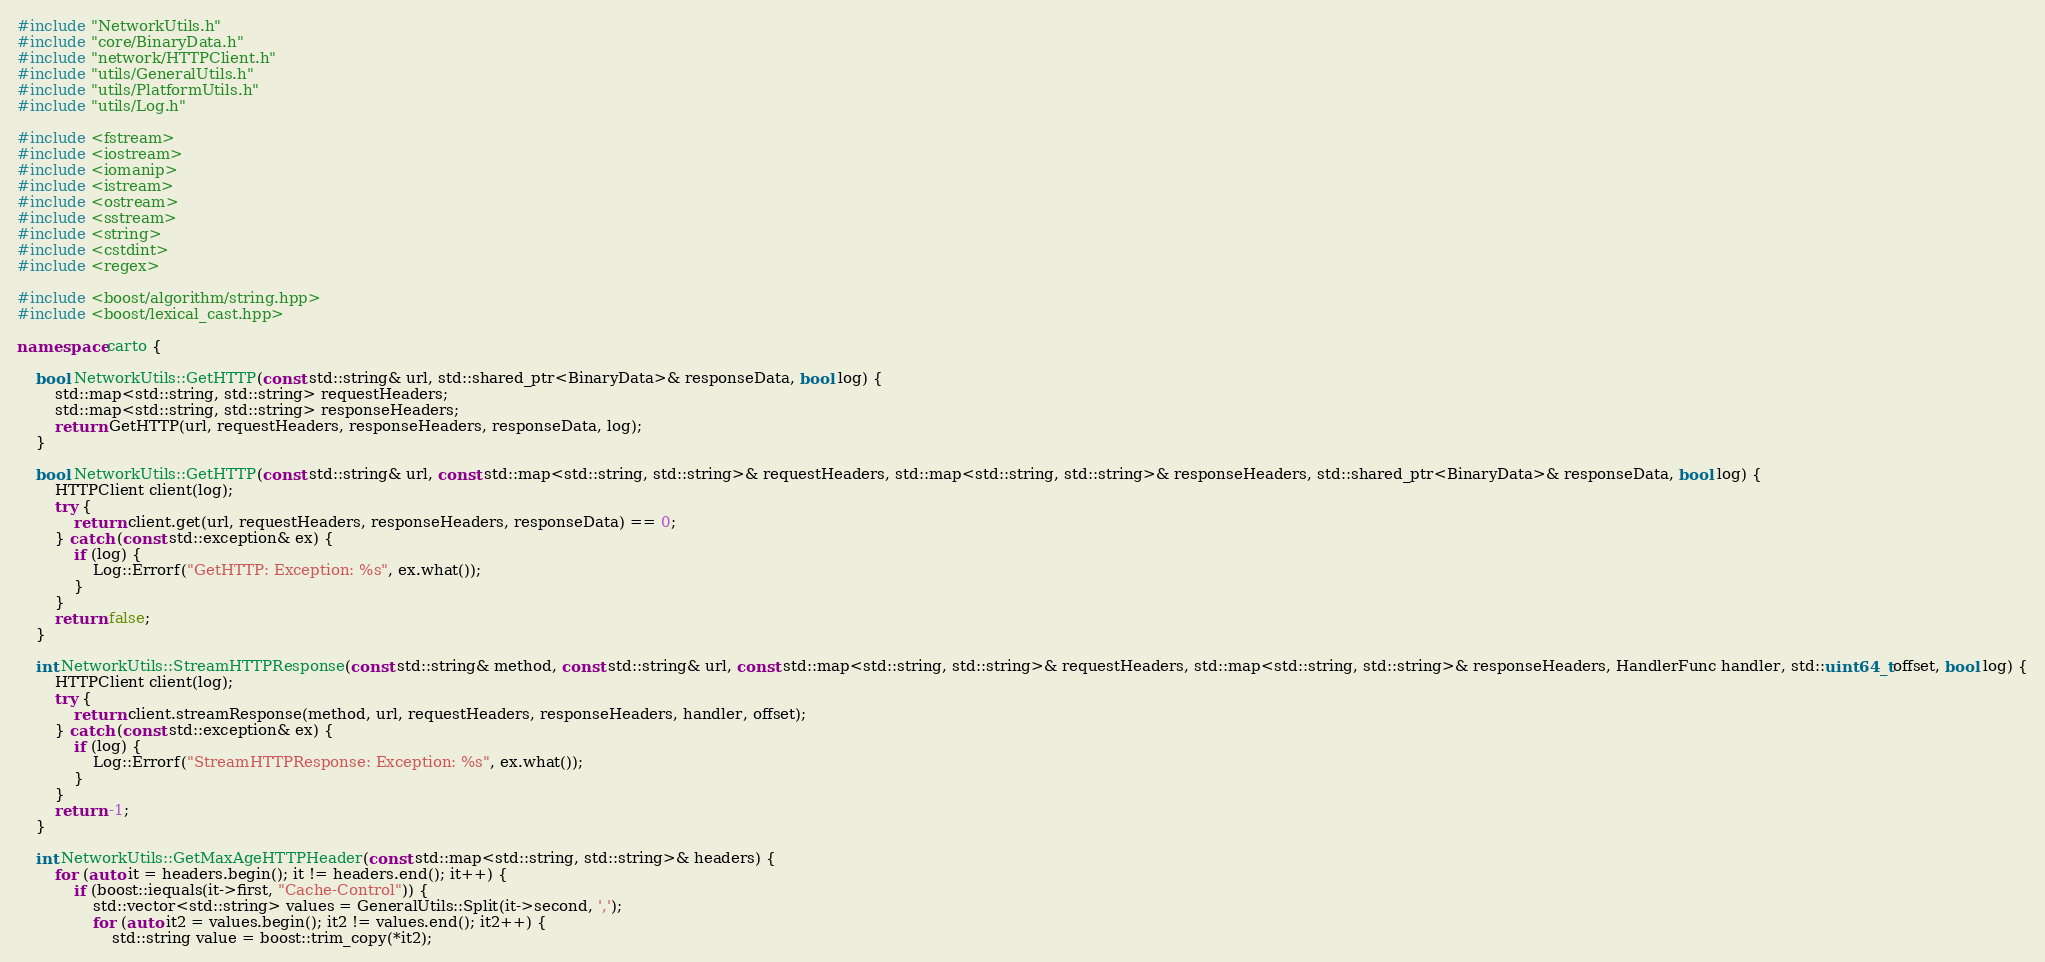<code> <loc_0><loc_0><loc_500><loc_500><_C++_>#include "NetworkUtils.h"
#include "core/BinaryData.h"
#include "network/HTTPClient.h"
#include "utils/GeneralUtils.h"
#include "utils/PlatformUtils.h"
#include "utils/Log.h"

#include <fstream>
#include <iostream>
#include <iomanip>
#include <istream>
#include <ostream>
#include <sstream>
#include <string>
#include <cstdint>
#include <regex>

#include <boost/algorithm/string.hpp>
#include <boost/lexical_cast.hpp>

namespace carto {
    
    bool NetworkUtils::GetHTTP(const std::string& url, std::shared_ptr<BinaryData>& responseData, bool log) {
        std::map<std::string, std::string> requestHeaders;
        std::map<std::string, std::string> responseHeaders;
        return GetHTTP(url, requestHeaders, responseHeaders, responseData, log);
    }

    bool NetworkUtils::GetHTTP(const std::string& url, const std::map<std::string, std::string>& requestHeaders, std::map<std::string, std::string>& responseHeaders, std::shared_ptr<BinaryData>& responseData, bool log) {
        HTTPClient client(log);
        try {
            return client.get(url, requestHeaders, responseHeaders, responseData) == 0;
        } catch (const std::exception& ex) {
            if (log) {
                Log::Errorf("GetHTTP: Exception: %s", ex.what());
            }
        }
        return false;
    }

    int NetworkUtils::StreamHTTPResponse(const std::string& method, const std::string& url, const std::map<std::string, std::string>& requestHeaders, std::map<std::string, std::string>& responseHeaders, HandlerFunc handler, std::uint64_t offset, bool log) {
        HTTPClient client(log);
        try {
            return client.streamResponse(method, url, requestHeaders, responseHeaders, handler, offset);
        } catch (const std::exception& ex) {
            if (log) {
                Log::Errorf("StreamHTTPResponse: Exception: %s", ex.what());
            }
        }
        return -1;
    }

    int NetworkUtils::GetMaxAgeHTTPHeader(const std::map<std::string, std::string>& headers) {
        for (auto it = headers.begin(); it != headers.end(); it++) {
            if (boost::iequals(it->first, "Cache-Control")) {
                std::vector<std::string> values = GeneralUtils::Split(it->second, ',');
                for (auto it2 = values.begin(); it2 != values.end(); it2++) {
                    std::string value = boost::trim_copy(*it2);</code> 